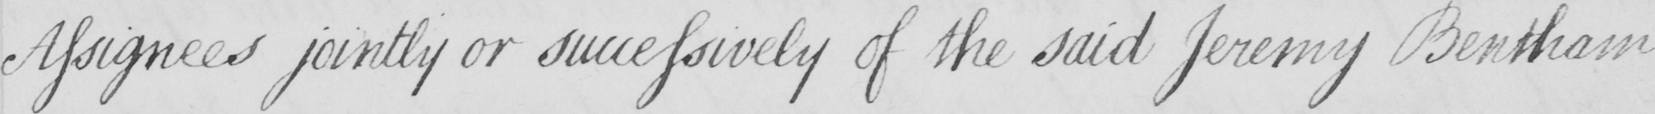Transcribe the text shown in this historical manuscript line. Assignees jointly or successively of the said Jeremy Bentham 